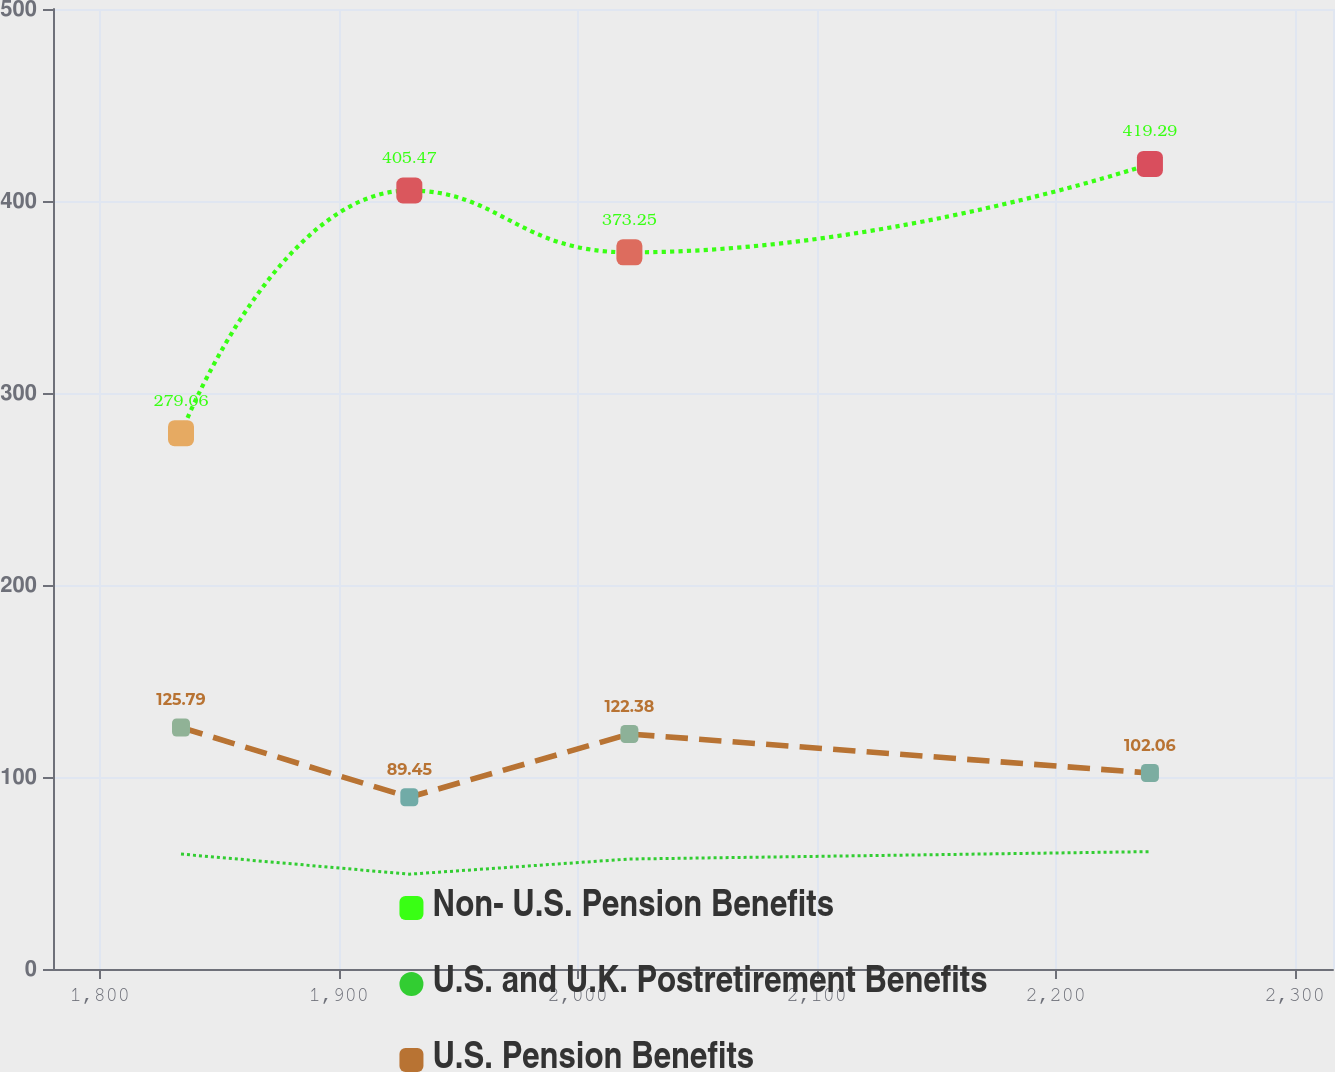Convert chart. <chart><loc_0><loc_0><loc_500><loc_500><line_chart><ecel><fcel>Non- U.S. Pension Benefits<fcel>U.S. and U.K. Postretirement Benefits<fcel>U.S. Pension Benefits<nl><fcel>1834<fcel>279.06<fcel>59.86<fcel>125.79<nl><fcel>1929.54<fcel>405.47<fcel>49.38<fcel>89.45<nl><fcel>2021.62<fcel>373.25<fcel>57.28<fcel>122.38<nl><fcel>2239.43<fcel>419.29<fcel>61.13<fcel>102.06<nl><fcel>2369.59<fcel>346.68<fcel>62.4<fcel>97.06<nl></chart> 